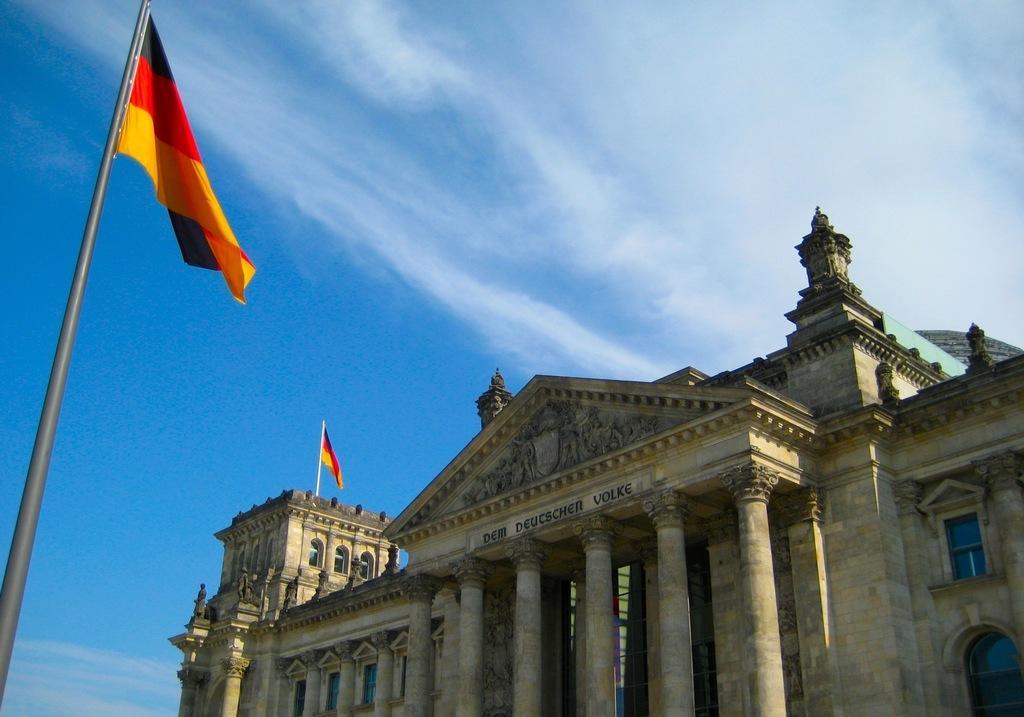How would you summarize this image in a sentence or two? In this picture, we can see building with pillars, and we can see flags, poles, and the sky with clouds. 